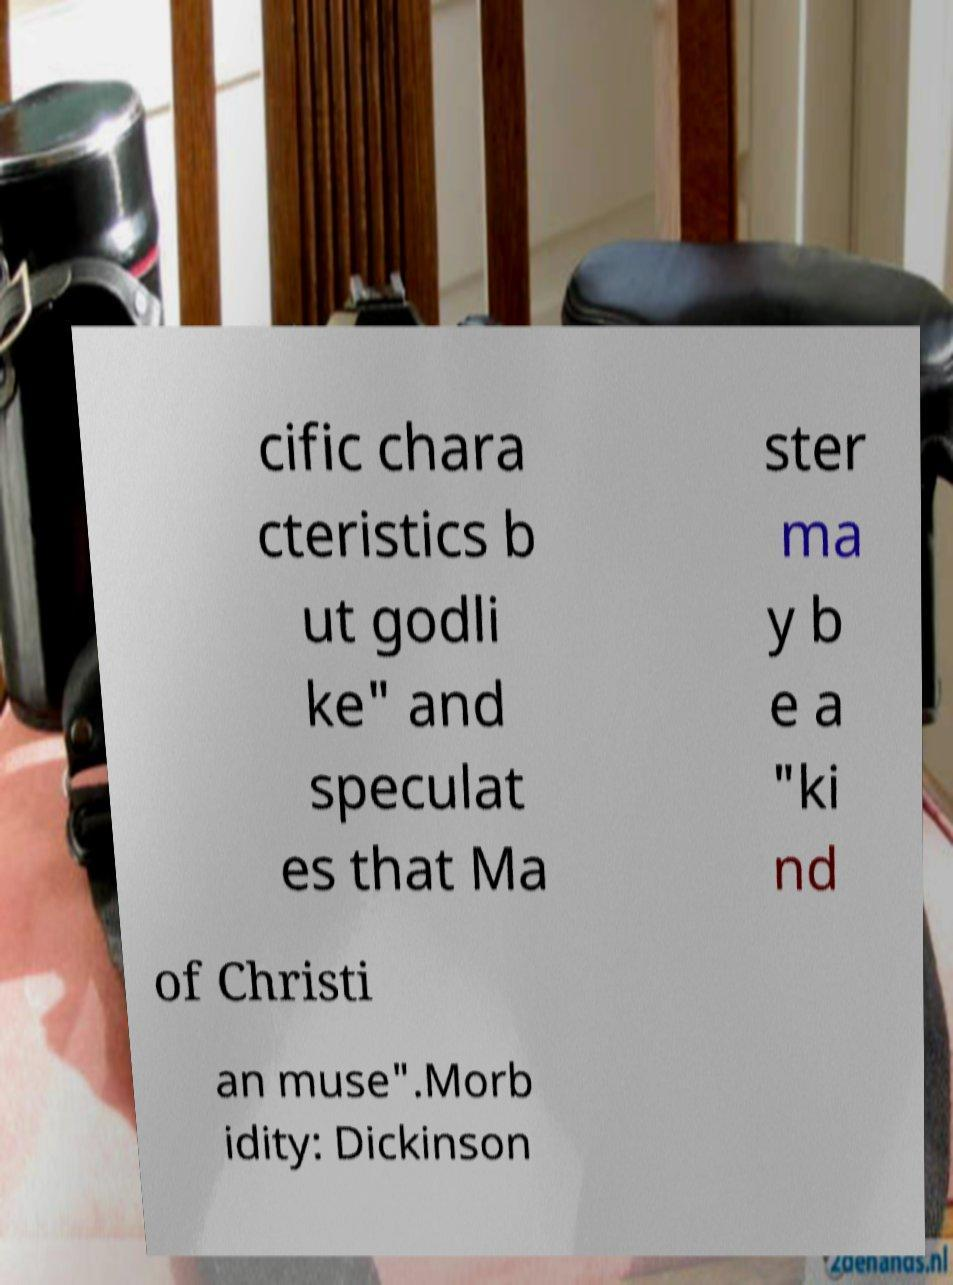What messages or text are displayed in this image? I need them in a readable, typed format. cific chara cteristics b ut godli ke" and speculat es that Ma ster ma y b e a "ki nd of Christi an muse".Morb idity: Dickinson 